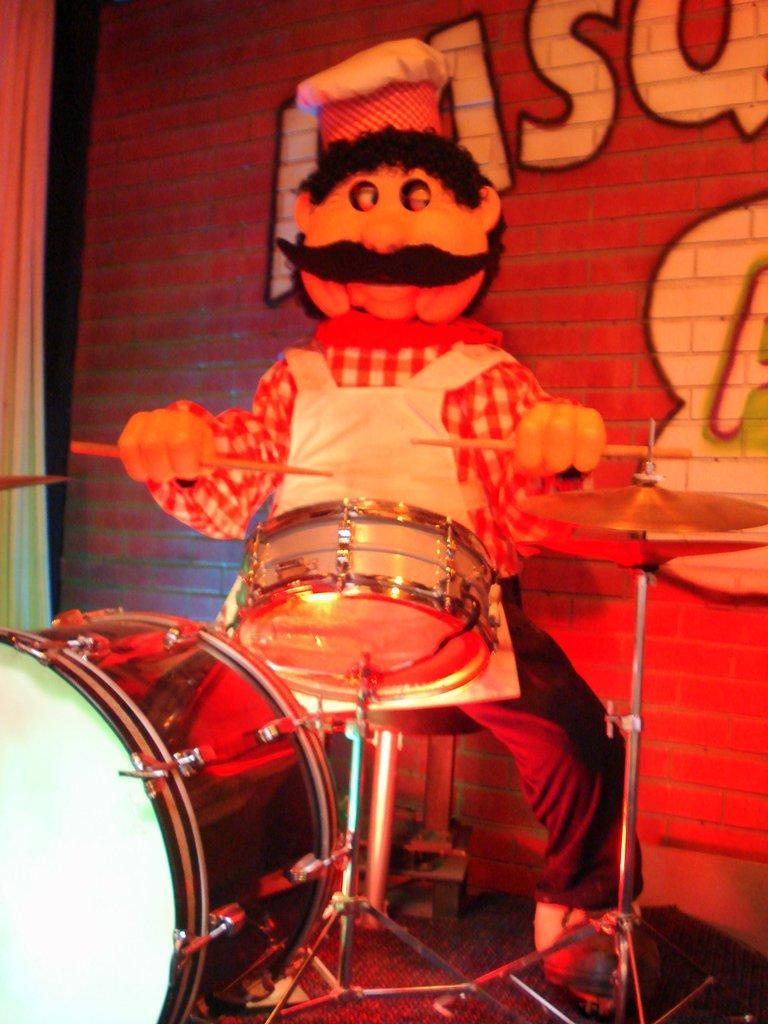Please provide a concise description of this image. In this picture, we see a man who is wearing a mascot costume is holding the sticks in his hands and he is playing the drums. Behind him, we see a wall which is made up of bricks. We see some text written on the wall. On the left side, we see a curtain. This picture might be clicked in the musical concert. 